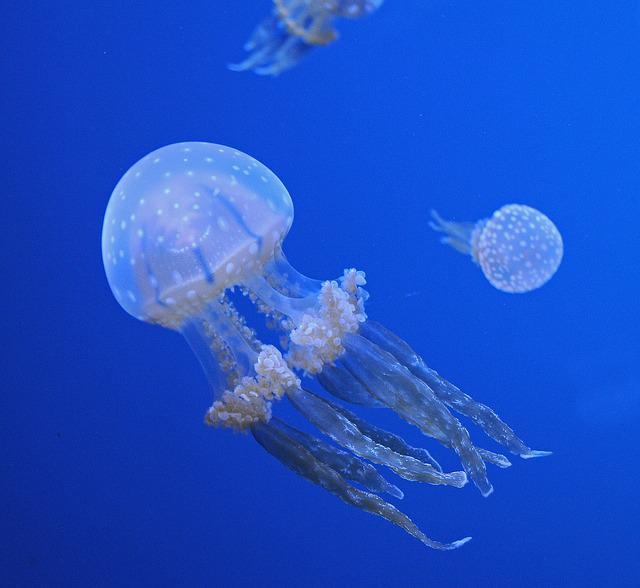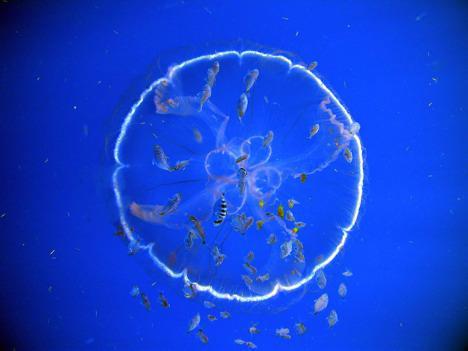The first image is the image on the left, the second image is the image on the right. Analyze the images presented: Is the assertion "The left image contains one round jellyfish with glowing white color, and the right image features a sea turtle next to a round shape." valid? Answer yes or no. No. The first image is the image on the left, the second image is the image on the right. For the images displayed, is the sentence "One of the images shows a tortoise interacting with a jellyfish." factually correct? Answer yes or no. No. 